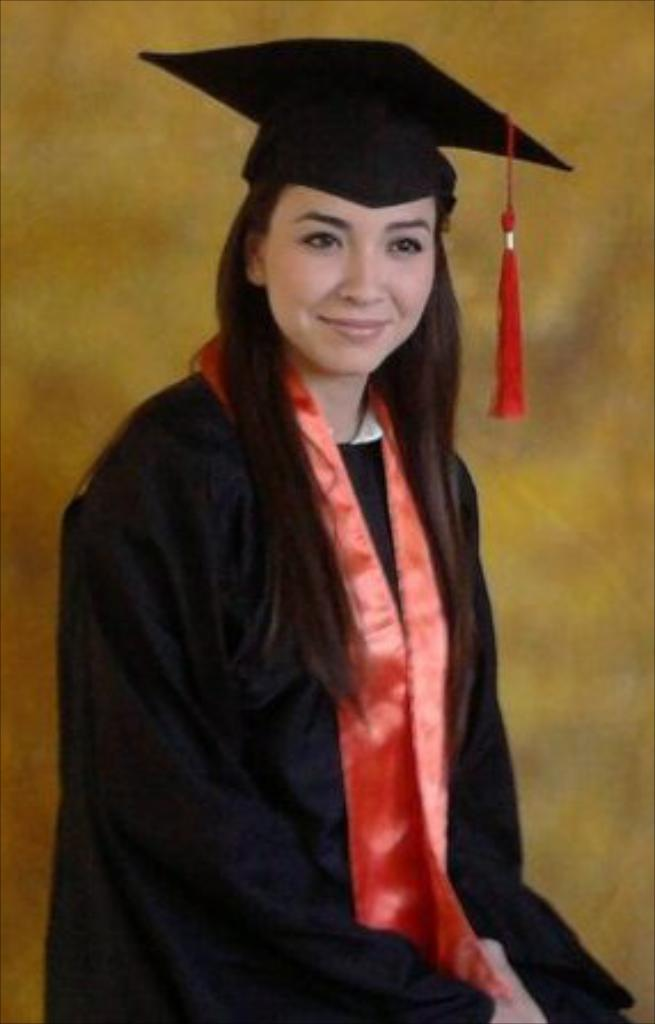What is present in the image? There is a person in the image. Can you describe the person's attire? The person is wearing a black and yellow color dress and a hat. What color is the background of the image? The background of the image is yellow. What type of key is the person holding in the image? There is no key present in the image; the person is wearing a hat and a black and yellow color dress. What kind of berry can be seen in the person's hand in the image? There is no berry present in the image; the person is wearing a hat and a black and yellow color dress. 